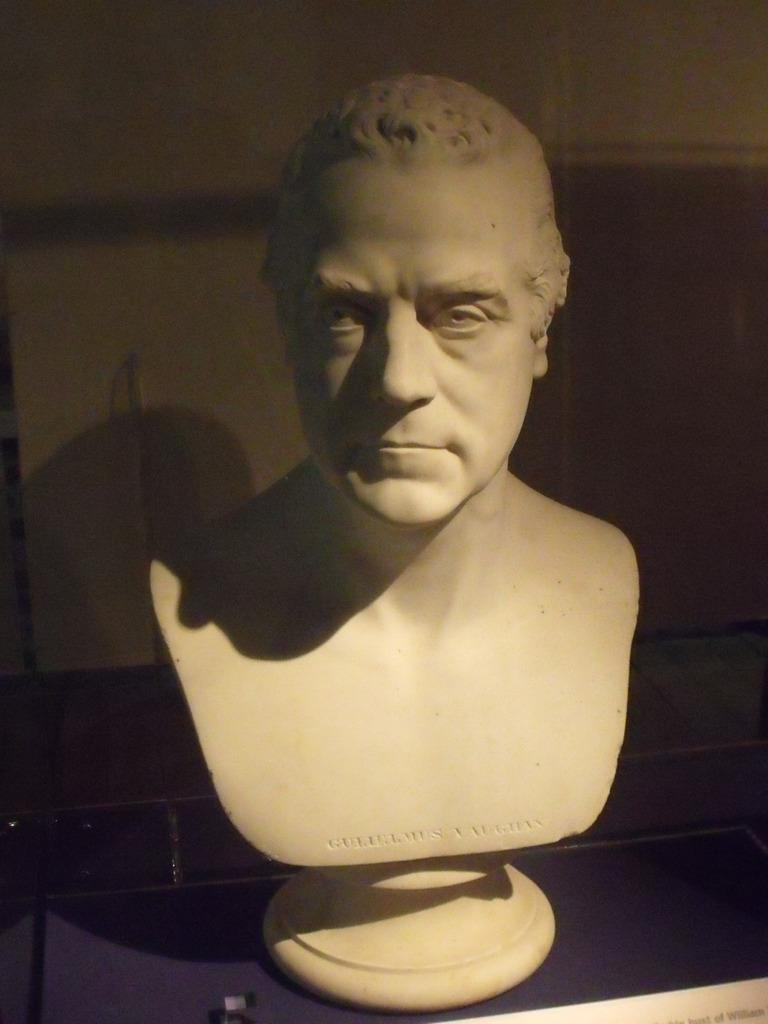What is the main subject in the image? There is a statue in the image. What is the opinion of the monkey about the statue in the image? There is no monkey present in the image, so it is not possible to determine its opinion about the statue. 